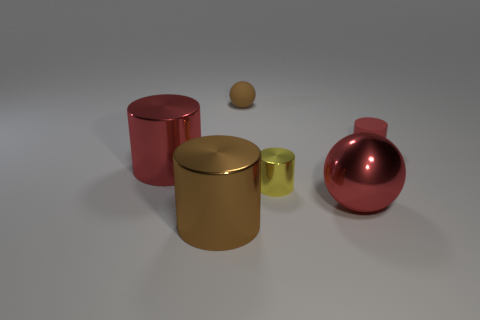Can you describe the materials the objects appear to be made of? Certainly! The objects in the image seem to have varying materials. The large cylindrical container and the sphere have a rubbery look, suggestive of a matte, soft texture. The smaller cylindrical container appears metallic, with a shiny, smooth surface that reflects light, possible aluminum or steel. The sphere between them has a similar sheen and could be made of a polished wood. 